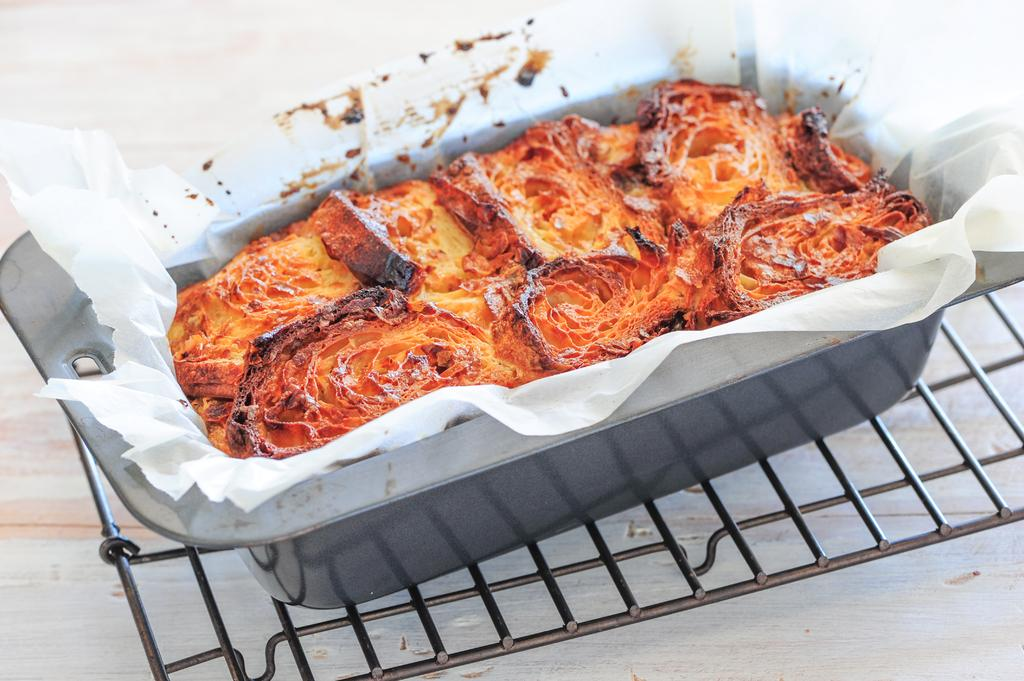What is in the bowl that is visible in the image? There are food items in a bowl in the image. Where is the bowl located in the image? The bowl is on a grill in the image. How many geese are present in the image? There are no geese present in the image. What type of food selection can be seen in the image? The image only shows food items in a bowl, so it is not possible to determine the type of food selection. 